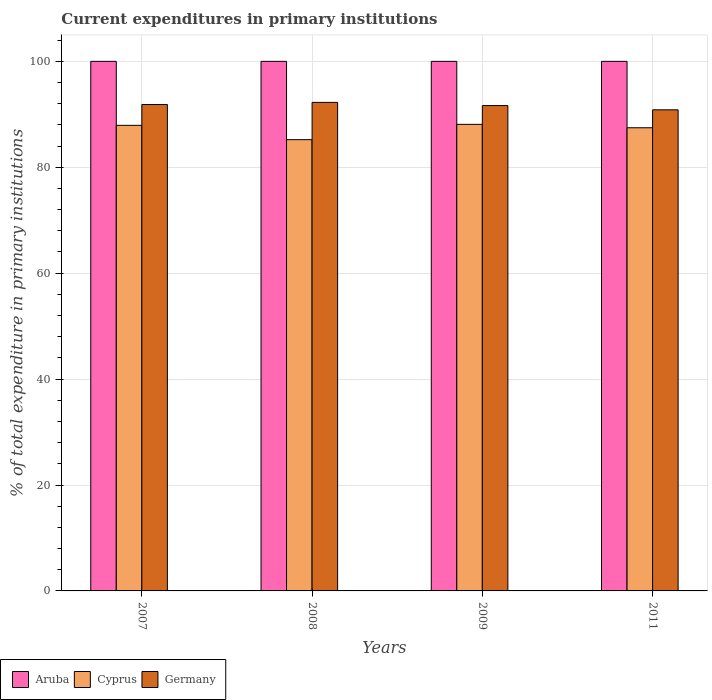How many different coloured bars are there?
Your response must be concise. 3. How many groups of bars are there?
Make the answer very short. 4. Are the number of bars on each tick of the X-axis equal?
Offer a very short reply. Yes. How many bars are there on the 3rd tick from the right?
Offer a terse response. 3. What is the label of the 2nd group of bars from the left?
Offer a very short reply. 2008. What is the current expenditures in primary institutions in Germany in 2007?
Provide a short and direct response. 91.85. Across all years, what is the maximum current expenditures in primary institutions in Cyprus?
Make the answer very short. 88.1. Across all years, what is the minimum current expenditures in primary institutions in Germany?
Your answer should be compact. 90.85. In which year was the current expenditures in primary institutions in Cyprus minimum?
Keep it short and to the point. 2008. What is the total current expenditures in primary institutions in Aruba in the graph?
Ensure brevity in your answer.  400. What is the difference between the current expenditures in primary institutions in Aruba in 2007 and that in 2009?
Offer a terse response. 0. What is the difference between the current expenditures in primary institutions in Cyprus in 2007 and the current expenditures in primary institutions in Germany in 2011?
Your answer should be compact. -2.93. What is the average current expenditures in primary institutions in Cyprus per year?
Offer a very short reply. 87.17. In the year 2011, what is the difference between the current expenditures in primary institutions in Germany and current expenditures in primary institutions in Cyprus?
Ensure brevity in your answer.  3.39. What is the ratio of the current expenditures in primary institutions in Germany in 2008 to that in 2011?
Make the answer very short. 1.02. Is the current expenditures in primary institutions in Germany in 2009 less than that in 2011?
Provide a short and direct response. No. What is the difference between the highest and the second highest current expenditures in primary institutions in Germany?
Your answer should be very brief. 0.4. In how many years, is the current expenditures in primary institutions in Germany greater than the average current expenditures in primary institutions in Germany taken over all years?
Provide a succinct answer. 3. What does the 1st bar from the left in 2009 represents?
Provide a succinct answer. Aruba. What does the 3rd bar from the right in 2011 represents?
Offer a very short reply. Aruba. How many bars are there?
Provide a short and direct response. 12. How many years are there in the graph?
Ensure brevity in your answer.  4. Are the values on the major ticks of Y-axis written in scientific E-notation?
Provide a short and direct response. No. Does the graph contain any zero values?
Provide a succinct answer. No. Does the graph contain grids?
Offer a very short reply. Yes. How are the legend labels stacked?
Keep it short and to the point. Horizontal. What is the title of the graph?
Make the answer very short. Current expenditures in primary institutions. Does "Nepal" appear as one of the legend labels in the graph?
Ensure brevity in your answer.  No. What is the label or title of the X-axis?
Provide a short and direct response. Years. What is the label or title of the Y-axis?
Your response must be concise. % of total expenditure in primary institutions. What is the % of total expenditure in primary institutions in Cyprus in 2007?
Give a very brief answer. 87.92. What is the % of total expenditure in primary institutions of Germany in 2007?
Give a very brief answer. 91.85. What is the % of total expenditure in primary institutions of Aruba in 2008?
Ensure brevity in your answer.  100. What is the % of total expenditure in primary institutions in Cyprus in 2008?
Provide a short and direct response. 85.21. What is the % of total expenditure in primary institutions of Germany in 2008?
Your answer should be compact. 92.25. What is the % of total expenditure in primary institutions of Cyprus in 2009?
Provide a succinct answer. 88.1. What is the % of total expenditure in primary institutions in Germany in 2009?
Keep it short and to the point. 91.65. What is the % of total expenditure in primary institutions in Cyprus in 2011?
Your answer should be very brief. 87.46. What is the % of total expenditure in primary institutions of Germany in 2011?
Provide a short and direct response. 90.85. Across all years, what is the maximum % of total expenditure in primary institutions in Aruba?
Make the answer very short. 100. Across all years, what is the maximum % of total expenditure in primary institutions of Cyprus?
Provide a short and direct response. 88.1. Across all years, what is the maximum % of total expenditure in primary institutions of Germany?
Your response must be concise. 92.25. Across all years, what is the minimum % of total expenditure in primary institutions in Aruba?
Offer a terse response. 100. Across all years, what is the minimum % of total expenditure in primary institutions of Cyprus?
Provide a short and direct response. 85.21. Across all years, what is the minimum % of total expenditure in primary institutions in Germany?
Make the answer very short. 90.85. What is the total % of total expenditure in primary institutions in Aruba in the graph?
Ensure brevity in your answer.  400. What is the total % of total expenditure in primary institutions of Cyprus in the graph?
Give a very brief answer. 348.69. What is the total % of total expenditure in primary institutions of Germany in the graph?
Your answer should be compact. 366.6. What is the difference between the % of total expenditure in primary institutions of Cyprus in 2007 and that in 2008?
Your answer should be compact. 2.7. What is the difference between the % of total expenditure in primary institutions of Germany in 2007 and that in 2008?
Your answer should be very brief. -0.4. What is the difference between the % of total expenditure in primary institutions of Aruba in 2007 and that in 2009?
Your response must be concise. 0. What is the difference between the % of total expenditure in primary institutions of Cyprus in 2007 and that in 2009?
Offer a very short reply. -0.19. What is the difference between the % of total expenditure in primary institutions of Germany in 2007 and that in 2009?
Offer a terse response. 0.2. What is the difference between the % of total expenditure in primary institutions of Aruba in 2007 and that in 2011?
Provide a succinct answer. 0. What is the difference between the % of total expenditure in primary institutions in Cyprus in 2007 and that in 2011?
Provide a succinct answer. 0.46. What is the difference between the % of total expenditure in primary institutions of Aruba in 2008 and that in 2009?
Offer a terse response. 0. What is the difference between the % of total expenditure in primary institutions in Cyprus in 2008 and that in 2009?
Provide a short and direct response. -2.89. What is the difference between the % of total expenditure in primary institutions of Germany in 2008 and that in 2009?
Give a very brief answer. 0.6. What is the difference between the % of total expenditure in primary institutions in Aruba in 2008 and that in 2011?
Offer a very short reply. 0. What is the difference between the % of total expenditure in primary institutions of Cyprus in 2008 and that in 2011?
Your answer should be compact. -2.25. What is the difference between the % of total expenditure in primary institutions of Germany in 2008 and that in 2011?
Offer a very short reply. 1.4. What is the difference between the % of total expenditure in primary institutions of Cyprus in 2009 and that in 2011?
Provide a succinct answer. 0.64. What is the difference between the % of total expenditure in primary institutions of Germany in 2009 and that in 2011?
Offer a very short reply. 0.8. What is the difference between the % of total expenditure in primary institutions in Aruba in 2007 and the % of total expenditure in primary institutions in Cyprus in 2008?
Give a very brief answer. 14.79. What is the difference between the % of total expenditure in primary institutions of Aruba in 2007 and the % of total expenditure in primary institutions of Germany in 2008?
Provide a succinct answer. 7.75. What is the difference between the % of total expenditure in primary institutions in Cyprus in 2007 and the % of total expenditure in primary institutions in Germany in 2008?
Offer a terse response. -4.33. What is the difference between the % of total expenditure in primary institutions of Aruba in 2007 and the % of total expenditure in primary institutions of Cyprus in 2009?
Make the answer very short. 11.9. What is the difference between the % of total expenditure in primary institutions of Aruba in 2007 and the % of total expenditure in primary institutions of Germany in 2009?
Provide a short and direct response. 8.35. What is the difference between the % of total expenditure in primary institutions in Cyprus in 2007 and the % of total expenditure in primary institutions in Germany in 2009?
Offer a very short reply. -3.73. What is the difference between the % of total expenditure in primary institutions of Aruba in 2007 and the % of total expenditure in primary institutions of Cyprus in 2011?
Ensure brevity in your answer.  12.54. What is the difference between the % of total expenditure in primary institutions of Aruba in 2007 and the % of total expenditure in primary institutions of Germany in 2011?
Your answer should be very brief. 9.15. What is the difference between the % of total expenditure in primary institutions of Cyprus in 2007 and the % of total expenditure in primary institutions of Germany in 2011?
Your response must be concise. -2.93. What is the difference between the % of total expenditure in primary institutions in Aruba in 2008 and the % of total expenditure in primary institutions in Cyprus in 2009?
Give a very brief answer. 11.9. What is the difference between the % of total expenditure in primary institutions in Aruba in 2008 and the % of total expenditure in primary institutions in Germany in 2009?
Your response must be concise. 8.35. What is the difference between the % of total expenditure in primary institutions of Cyprus in 2008 and the % of total expenditure in primary institutions of Germany in 2009?
Provide a short and direct response. -6.44. What is the difference between the % of total expenditure in primary institutions in Aruba in 2008 and the % of total expenditure in primary institutions in Cyprus in 2011?
Offer a terse response. 12.54. What is the difference between the % of total expenditure in primary institutions of Aruba in 2008 and the % of total expenditure in primary institutions of Germany in 2011?
Provide a succinct answer. 9.15. What is the difference between the % of total expenditure in primary institutions of Cyprus in 2008 and the % of total expenditure in primary institutions of Germany in 2011?
Your answer should be very brief. -5.64. What is the difference between the % of total expenditure in primary institutions of Aruba in 2009 and the % of total expenditure in primary institutions of Cyprus in 2011?
Make the answer very short. 12.54. What is the difference between the % of total expenditure in primary institutions in Aruba in 2009 and the % of total expenditure in primary institutions in Germany in 2011?
Your answer should be compact. 9.15. What is the difference between the % of total expenditure in primary institutions in Cyprus in 2009 and the % of total expenditure in primary institutions in Germany in 2011?
Your answer should be compact. -2.74. What is the average % of total expenditure in primary institutions of Cyprus per year?
Ensure brevity in your answer.  87.17. What is the average % of total expenditure in primary institutions in Germany per year?
Provide a short and direct response. 91.65. In the year 2007, what is the difference between the % of total expenditure in primary institutions of Aruba and % of total expenditure in primary institutions of Cyprus?
Your response must be concise. 12.08. In the year 2007, what is the difference between the % of total expenditure in primary institutions in Aruba and % of total expenditure in primary institutions in Germany?
Your answer should be very brief. 8.15. In the year 2007, what is the difference between the % of total expenditure in primary institutions of Cyprus and % of total expenditure in primary institutions of Germany?
Offer a terse response. -3.93. In the year 2008, what is the difference between the % of total expenditure in primary institutions in Aruba and % of total expenditure in primary institutions in Cyprus?
Provide a short and direct response. 14.79. In the year 2008, what is the difference between the % of total expenditure in primary institutions in Aruba and % of total expenditure in primary institutions in Germany?
Provide a short and direct response. 7.75. In the year 2008, what is the difference between the % of total expenditure in primary institutions in Cyprus and % of total expenditure in primary institutions in Germany?
Ensure brevity in your answer.  -7.04. In the year 2009, what is the difference between the % of total expenditure in primary institutions in Aruba and % of total expenditure in primary institutions in Cyprus?
Your answer should be compact. 11.9. In the year 2009, what is the difference between the % of total expenditure in primary institutions of Aruba and % of total expenditure in primary institutions of Germany?
Provide a short and direct response. 8.35. In the year 2009, what is the difference between the % of total expenditure in primary institutions in Cyprus and % of total expenditure in primary institutions in Germany?
Keep it short and to the point. -3.55. In the year 2011, what is the difference between the % of total expenditure in primary institutions of Aruba and % of total expenditure in primary institutions of Cyprus?
Your answer should be compact. 12.54. In the year 2011, what is the difference between the % of total expenditure in primary institutions in Aruba and % of total expenditure in primary institutions in Germany?
Provide a succinct answer. 9.15. In the year 2011, what is the difference between the % of total expenditure in primary institutions of Cyprus and % of total expenditure in primary institutions of Germany?
Provide a short and direct response. -3.39. What is the ratio of the % of total expenditure in primary institutions in Cyprus in 2007 to that in 2008?
Your answer should be very brief. 1.03. What is the ratio of the % of total expenditure in primary institutions of Cyprus in 2007 to that in 2009?
Provide a succinct answer. 1. What is the ratio of the % of total expenditure in primary institutions in Germany in 2007 to that in 2009?
Offer a terse response. 1. What is the ratio of the % of total expenditure in primary institutions in Aruba in 2007 to that in 2011?
Ensure brevity in your answer.  1. What is the ratio of the % of total expenditure in primary institutions of Cyprus in 2007 to that in 2011?
Give a very brief answer. 1.01. What is the ratio of the % of total expenditure in primary institutions of Aruba in 2008 to that in 2009?
Offer a terse response. 1. What is the ratio of the % of total expenditure in primary institutions in Cyprus in 2008 to that in 2009?
Provide a short and direct response. 0.97. What is the ratio of the % of total expenditure in primary institutions of Germany in 2008 to that in 2009?
Your answer should be compact. 1.01. What is the ratio of the % of total expenditure in primary institutions of Aruba in 2008 to that in 2011?
Give a very brief answer. 1. What is the ratio of the % of total expenditure in primary institutions of Cyprus in 2008 to that in 2011?
Your answer should be very brief. 0.97. What is the ratio of the % of total expenditure in primary institutions of Germany in 2008 to that in 2011?
Ensure brevity in your answer.  1.02. What is the ratio of the % of total expenditure in primary institutions of Cyprus in 2009 to that in 2011?
Ensure brevity in your answer.  1.01. What is the ratio of the % of total expenditure in primary institutions in Germany in 2009 to that in 2011?
Make the answer very short. 1.01. What is the difference between the highest and the second highest % of total expenditure in primary institutions in Cyprus?
Offer a terse response. 0.19. What is the difference between the highest and the second highest % of total expenditure in primary institutions in Germany?
Give a very brief answer. 0.4. What is the difference between the highest and the lowest % of total expenditure in primary institutions in Cyprus?
Your response must be concise. 2.89. What is the difference between the highest and the lowest % of total expenditure in primary institutions in Germany?
Keep it short and to the point. 1.4. 